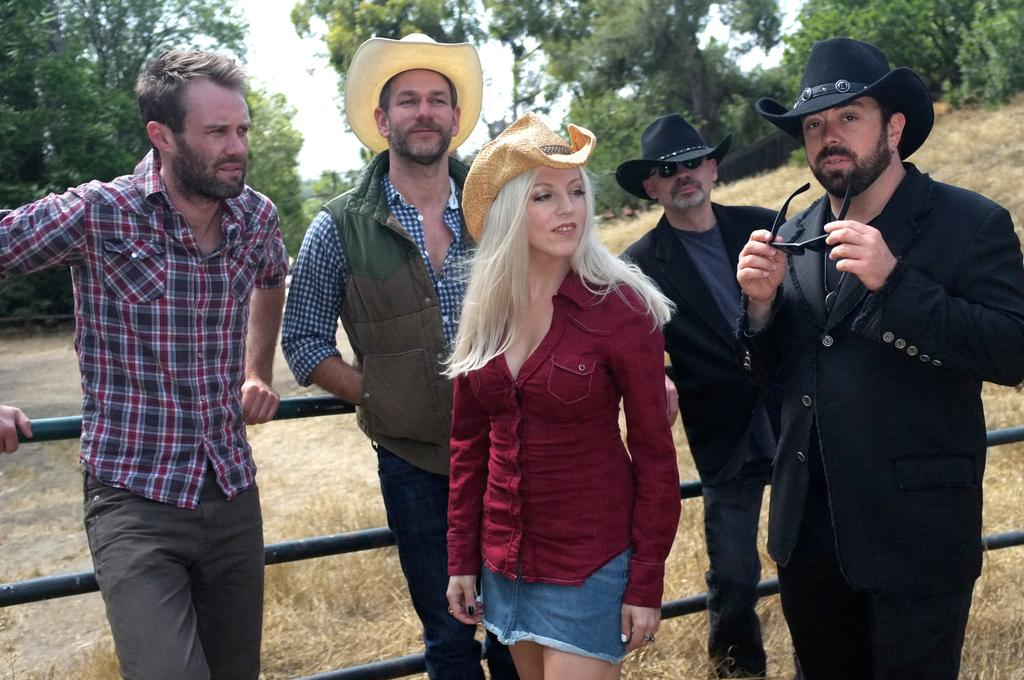What is happening in the image? There are people standing in the image. What can be seen near the people? There is a black color railing in the image. What type of natural environment is visible in the background? There are trees in the background of the image. What type of ground surface is at the bottom of the image? There is grass at the bottom of the image. What type of wood is used to make the pan in the image? There is no pan present in the image, so it is not possible to determine the type of wood used to make it. 